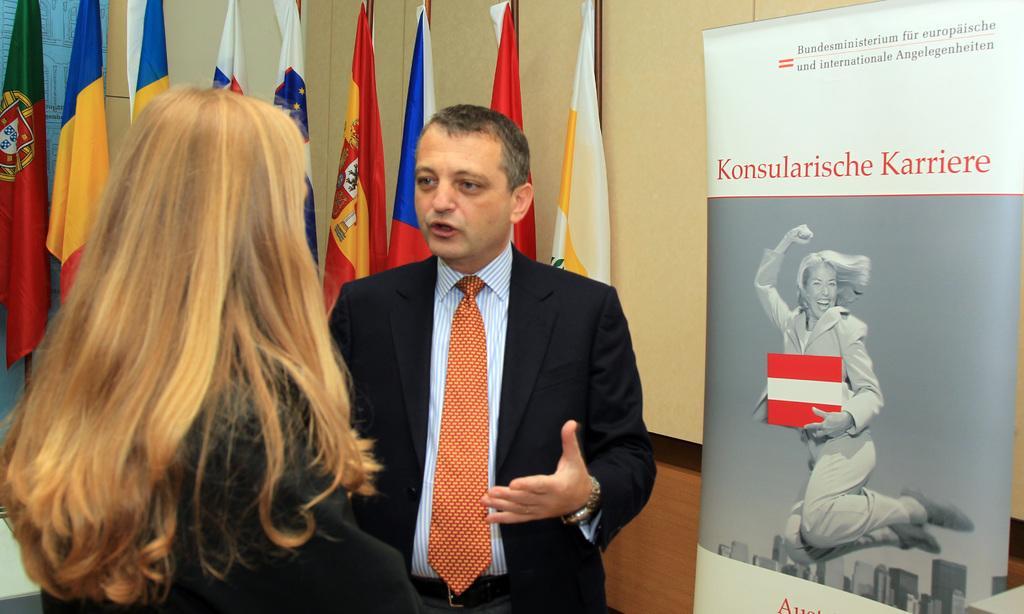In one or two sentences, can you explain what this image depicts? This picture might be taken inside the room. In this image, on the left side, we can see a woman wearing a black color dress is stunning. In the middle, we can also see a man wearing a black color suit is standing. On the right side, we can see a hoarding. In the background, there are some flags and a wall. 